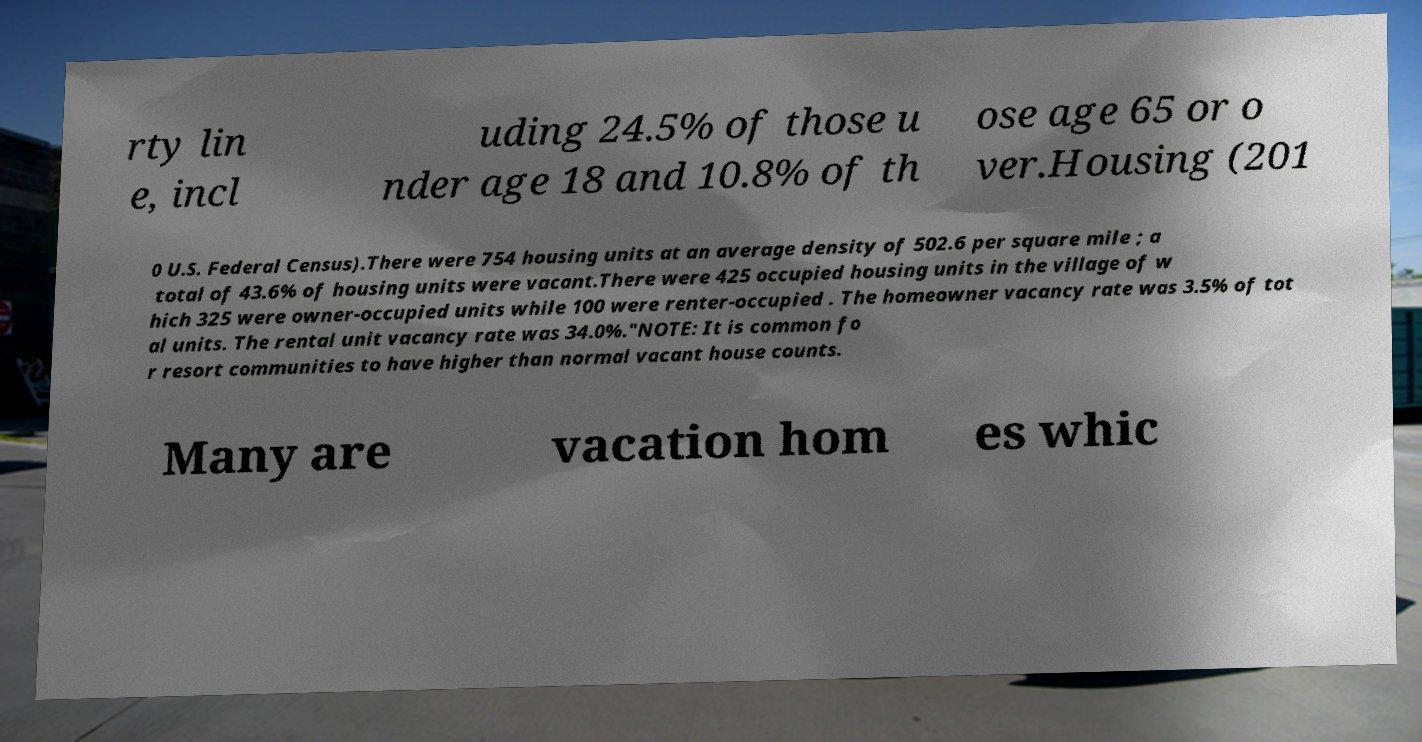Please identify and transcribe the text found in this image. rty lin e, incl uding 24.5% of those u nder age 18 and 10.8% of th ose age 65 or o ver.Housing (201 0 U.S. Federal Census).There were 754 housing units at an average density of 502.6 per square mile ; a total of 43.6% of housing units were vacant.There were 425 occupied housing units in the village of w hich 325 were owner-occupied units while 100 were renter-occupied . The homeowner vacancy rate was 3.5% of tot al units. The rental unit vacancy rate was 34.0%."NOTE: It is common fo r resort communities to have higher than normal vacant house counts. Many are vacation hom es whic 